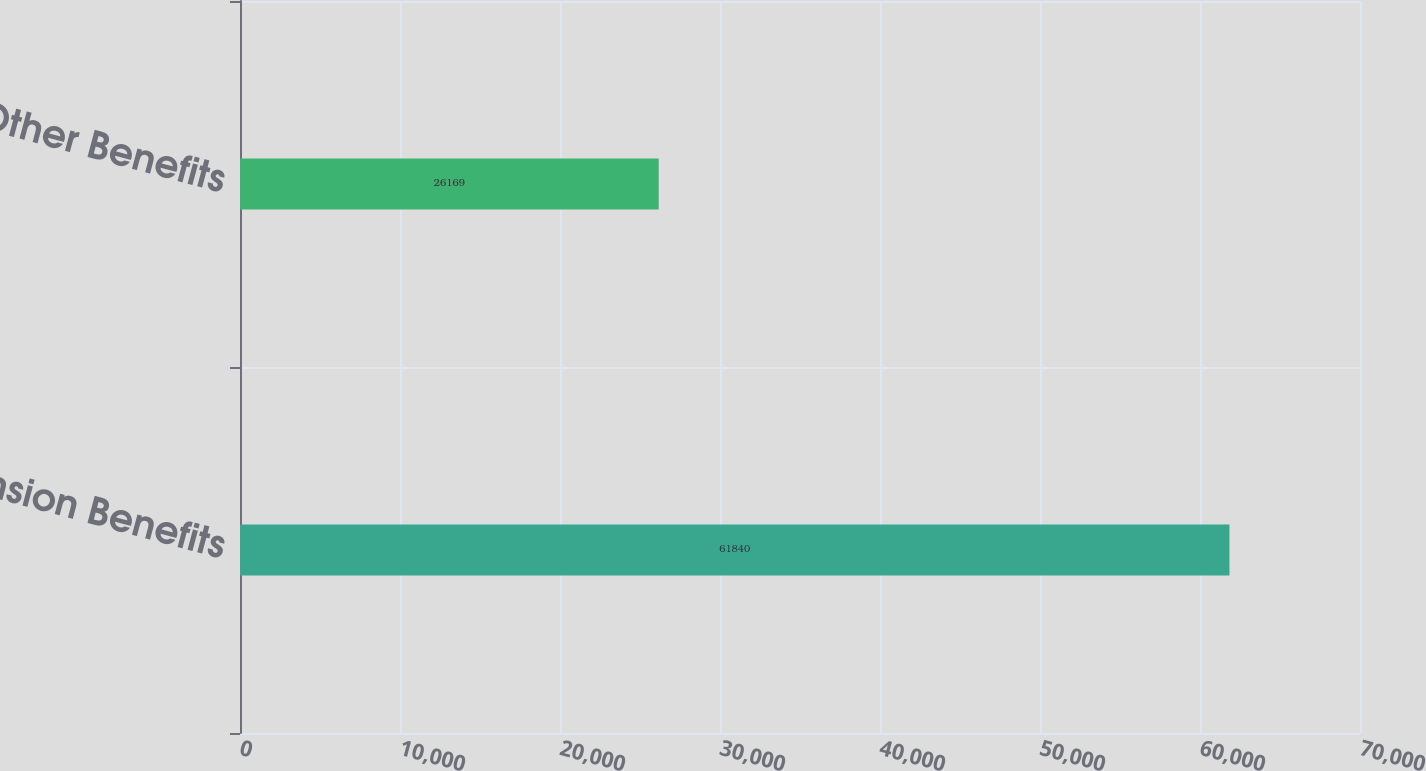<chart> <loc_0><loc_0><loc_500><loc_500><bar_chart><fcel>Pension Benefits<fcel>Other Benefits<nl><fcel>61840<fcel>26169<nl></chart> 